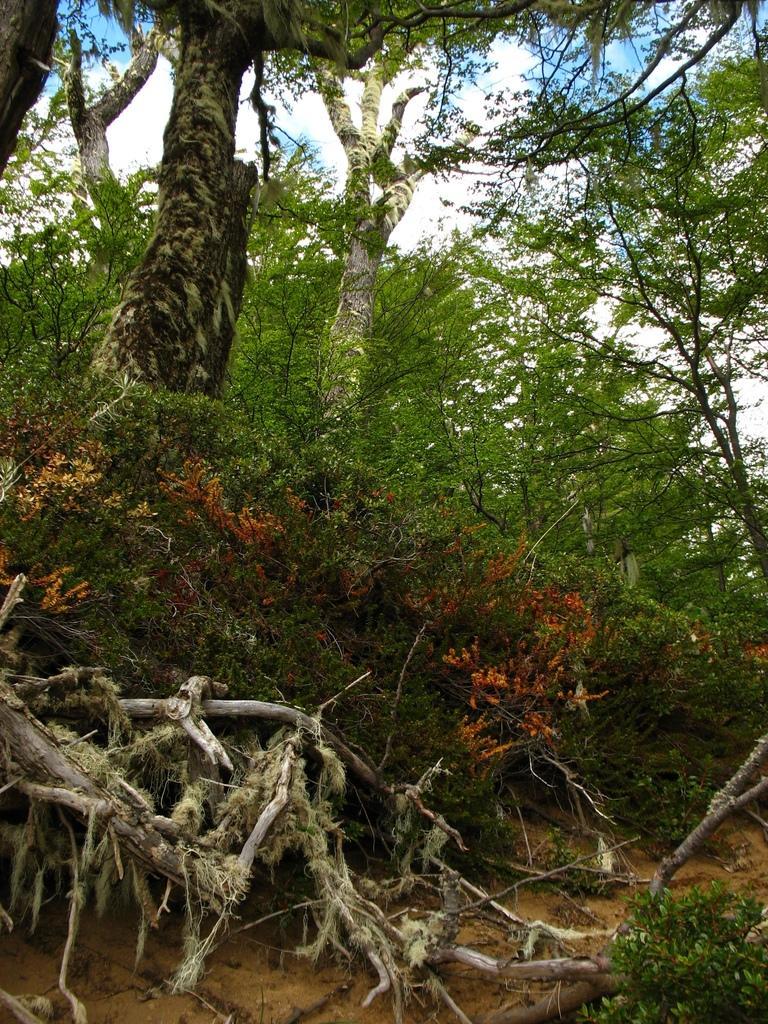Describe this image in one or two sentences. In this image I can see few trees which are green in color and few flowers which are orange in color. I can see the roots of the trees which are cream in color and the ground. In the background I can see the sky. 